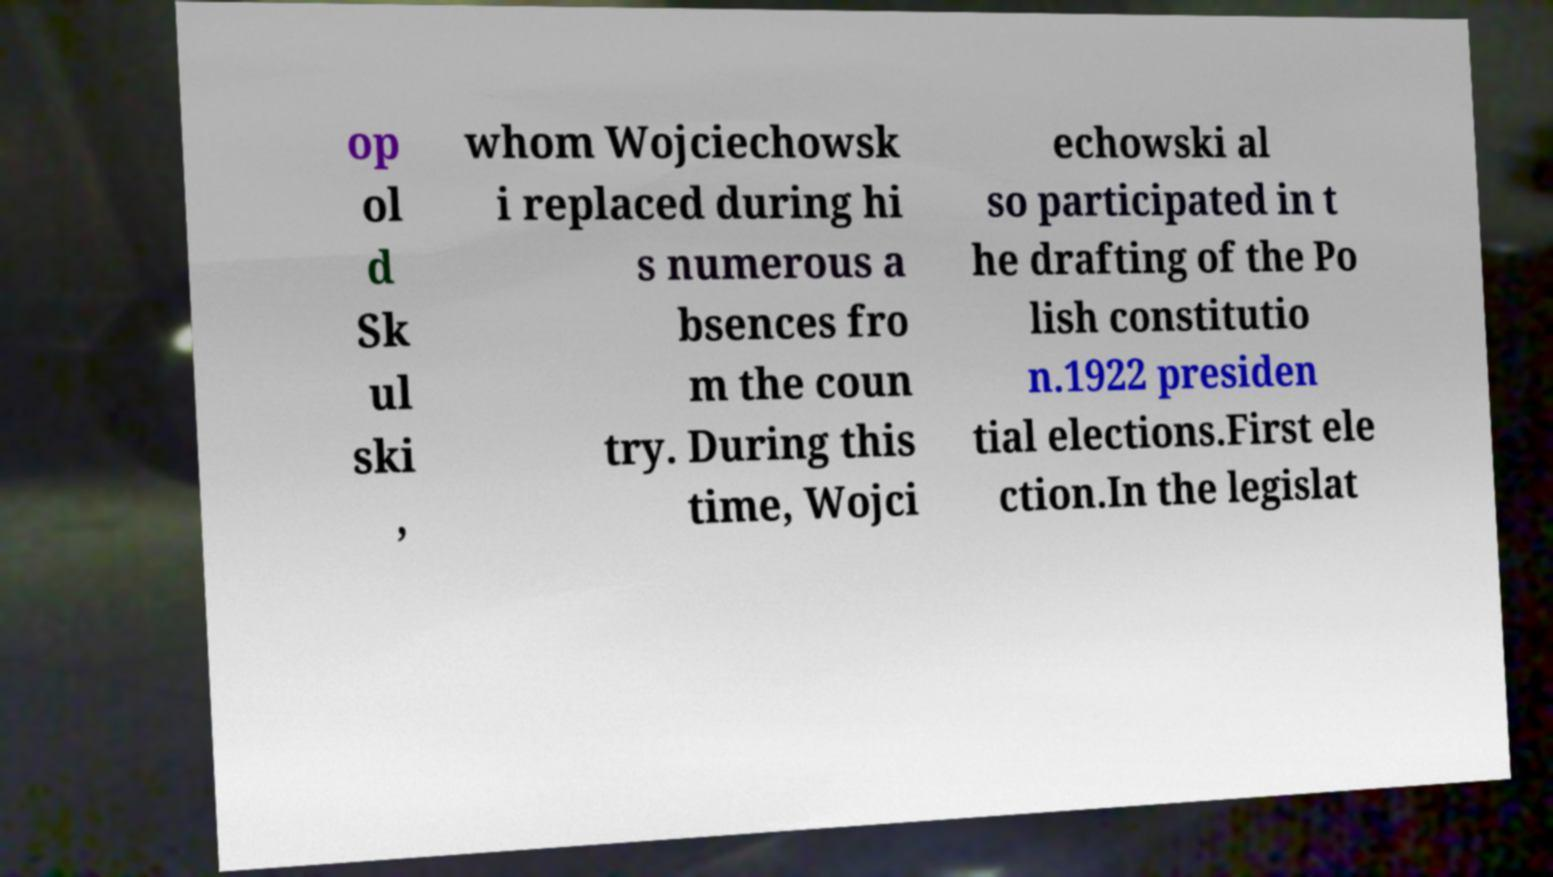Can you read and provide the text displayed in the image?This photo seems to have some interesting text. Can you extract and type it out for me? op ol d Sk ul ski , whom Wojciechowsk i replaced during hi s numerous a bsences fro m the coun try. During this time, Wojci echowski al so participated in t he drafting of the Po lish constitutio n.1922 presiden tial elections.First ele ction.In the legislat 